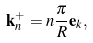<formula> <loc_0><loc_0><loc_500><loc_500>\mathbf k _ { n } ^ { + } = n \frac { \pi } { R } \mathbf e _ { k } ,</formula> 